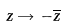Convert formula to latex. <formula><loc_0><loc_0><loc_500><loc_500>z \rightarrow - { \overline { z } }</formula> 